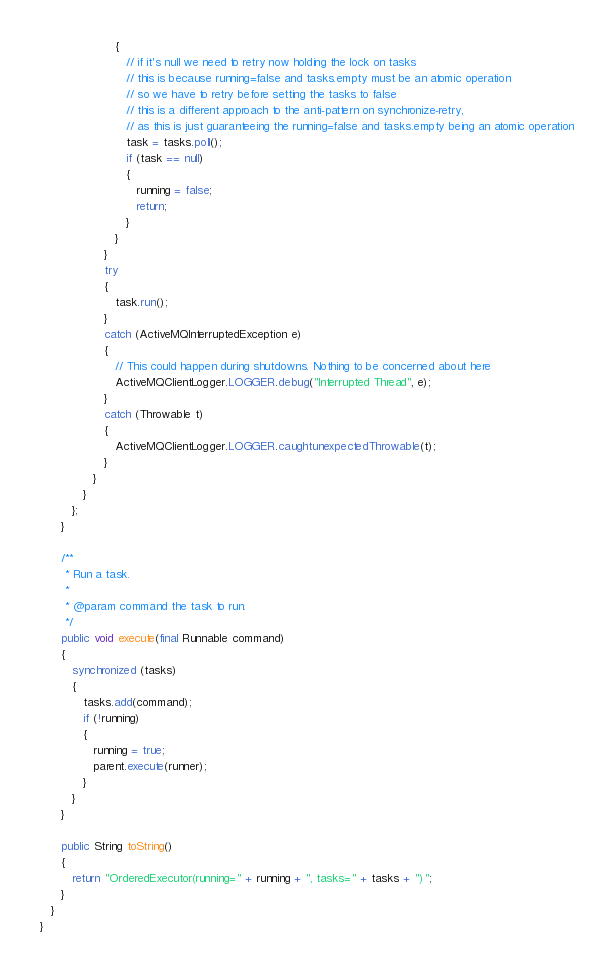<code> <loc_0><loc_0><loc_500><loc_500><_Java_>                     {
                        // if it's null we need to retry now holding the lock on tasks
                        // this is because running=false and tasks.empty must be an atomic operation
                        // so we have to retry before setting the tasks to false
                        // this is a different approach to the anti-pattern on synchronize-retry,
                        // as this is just guaranteeing the running=false and tasks.empty being an atomic operation
                        task = tasks.poll();
                        if (task == null)
                        {
                           running = false;
                           return;
                        }
                     }
                  }
                  try
                  {
                     task.run();
                  }
                  catch (ActiveMQInterruptedException e)
                  {
                     // This could happen during shutdowns. Nothing to be concerned about here
                     ActiveMQClientLogger.LOGGER.debug("Interrupted Thread", e);
                  }
                  catch (Throwable t)
                  {
                     ActiveMQClientLogger.LOGGER.caughtunexpectedThrowable(t);
                  }
               }
            }
         };
      }

      /**
       * Run a task.
       *
       * @param command the task to run.
       */
      public void execute(final Runnable command)
      {
         synchronized (tasks)
         {
            tasks.add(command);
            if (!running)
            {
               running = true;
               parent.execute(runner);
            }
         }
      }

      public String toString()
      {
         return "OrderedExecutor(running=" + running + ", tasks=" + tasks + ")";
      }
   }
}
</code> 